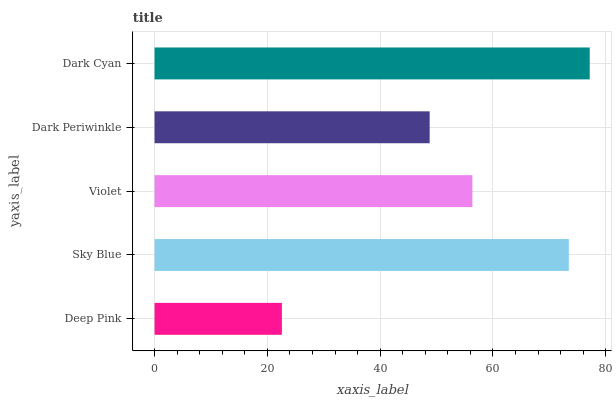Is Deep Pink the minimum?
Answer yes or no. Yes. Is Dark Cyan the maximum?
Answer yes or no. Yes. Is Sky Blue the minimum?
Answer yes or no. No. Is Sky Blue the maximum?
Answer yes or no. No. Is Sky Blue greater than Deep Pink?
Answer yes or no. Yes. Is Deep Pink less than Sky Blue?
Answer yes or no. Yes. Is Deep Pink greater than Sky Blue?
Answer yes or no. No. Is Sky Blue less than Deep Pink?
Answer yes or no. No. Is Violet the high median?
Answer yes or no. Yes. Is Violet the low median?
Answer yes or no. Yes. Is Dark Cyan the high median?
Answer yes or no. No. Is Dark Cyan the low median?
Answer yes or no. No. 